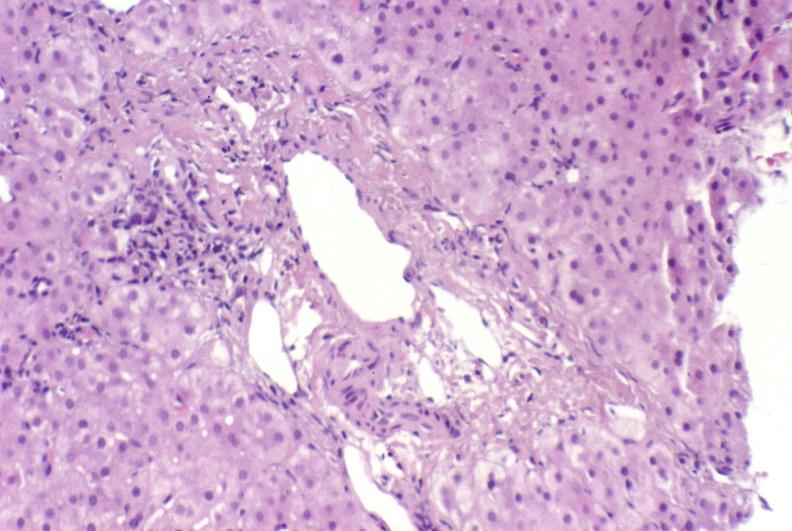s the tumor present?
Answer the question using a single word or phrase. No 